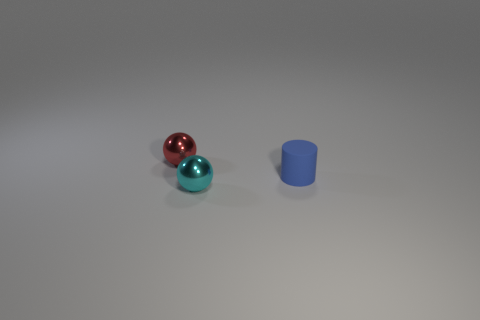Add 2 small blue rubber cylinders. How many objects exist? 5 Subtract all balls. How many objects are left? 1 Subtract 0 gray cylinders. How many objects are left? 3 Subtract all tiny metallic things. Subtract all tiny cyan balls. How many objects are left? 0 Add 1 tiny blue objects. How many tiny blue objects are left? 2 Add 2 red metal things. How many red metal things exist? 3 